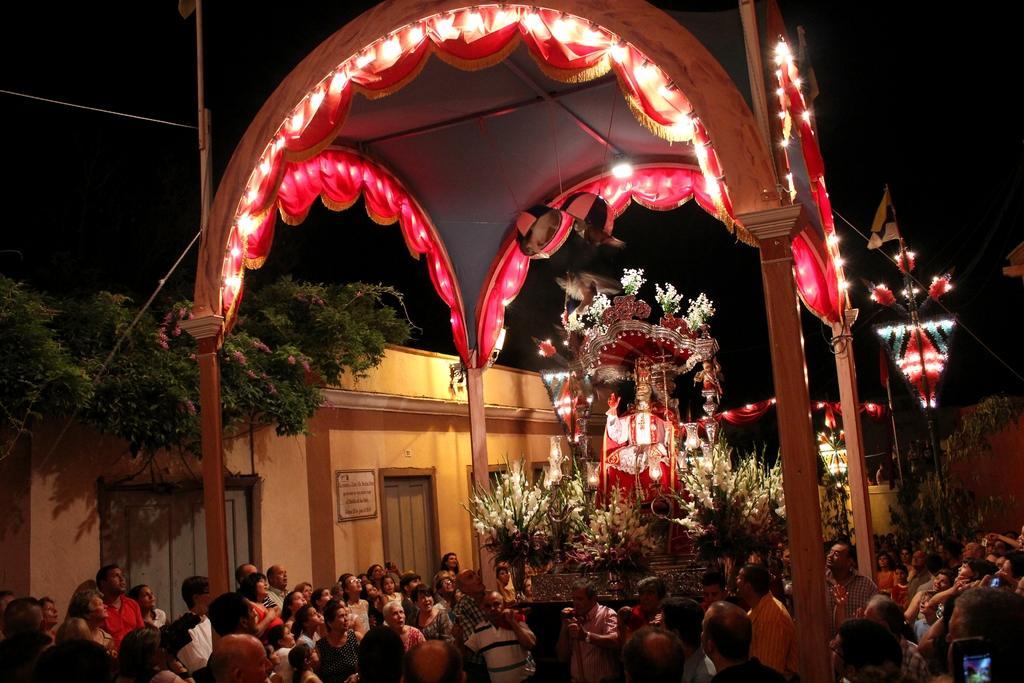How would you summarize this image in a sentence or two? In this image we can see arch, statue, flowers, lights, plants and we can also see people standing and looking towards the statue. 